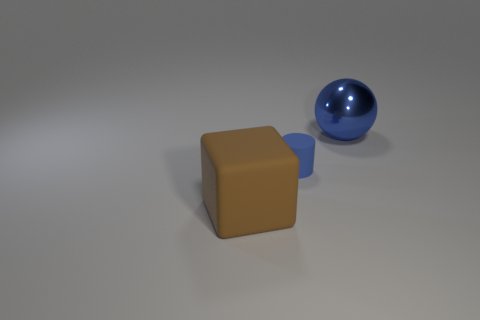Add 2 large brown objects. How many objects exist? 5 Subtract 0 brown balls. How many objects are left? 3 Subtract all cubes. How many objects are left? 2 Subtract all yellow cylinders. Subtract all green cubes. How many cylinders are left? 1 Subtract all big blue matte objects. Subtract all tiny objects. How many objects are left? 2 Add 2 small blue matte objects. How many small blue matte objects are left? 3 Add 2 cubes. How many cubes exist? 3 